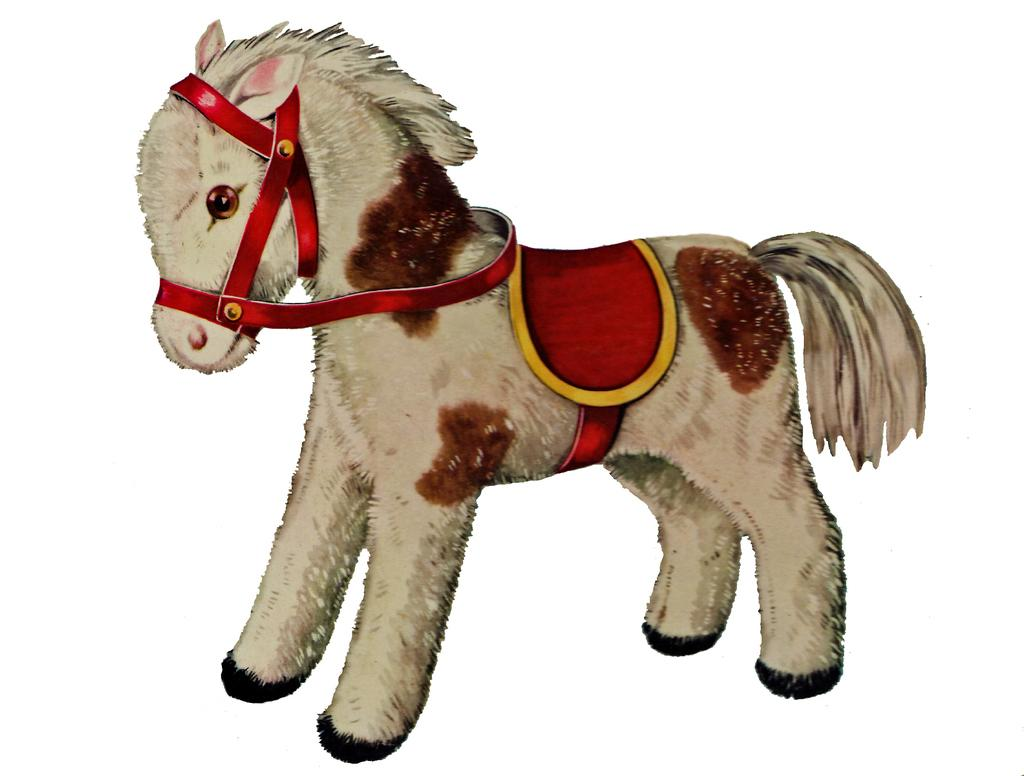What is the main subject of the image? There is a pony horse picture in the image. What color is the background of the image? The background of the image is white in color. How many cushions are present in the image? There is no mention of cushions in the provided facts, so it cannot be determined from the image. 